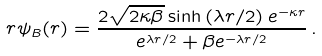<formula> <loc_0><loc_0><loc_500><loc_500>r \psi _ { B } ( r ) = \frac { 2 \sqrt { 2 \kappa \beta } \sinh \left ( \lambda r / 2 \right ) e ^ { - \kappa r } } { e ^ { \lambda r / 2 } + \beta e ^ { - \lambda r / 2 } } \, .</formula> 